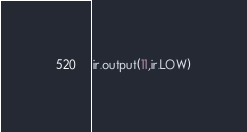<code> <loc_0><loc_0><loc_500><loc_500><_Python_>ir.output(11,ir.LOW)
</code> 